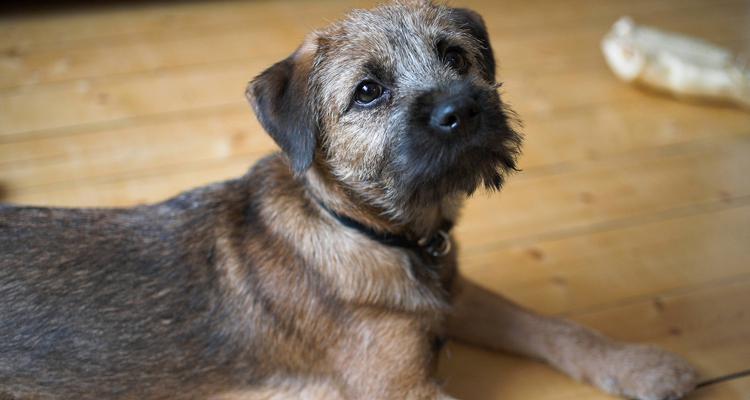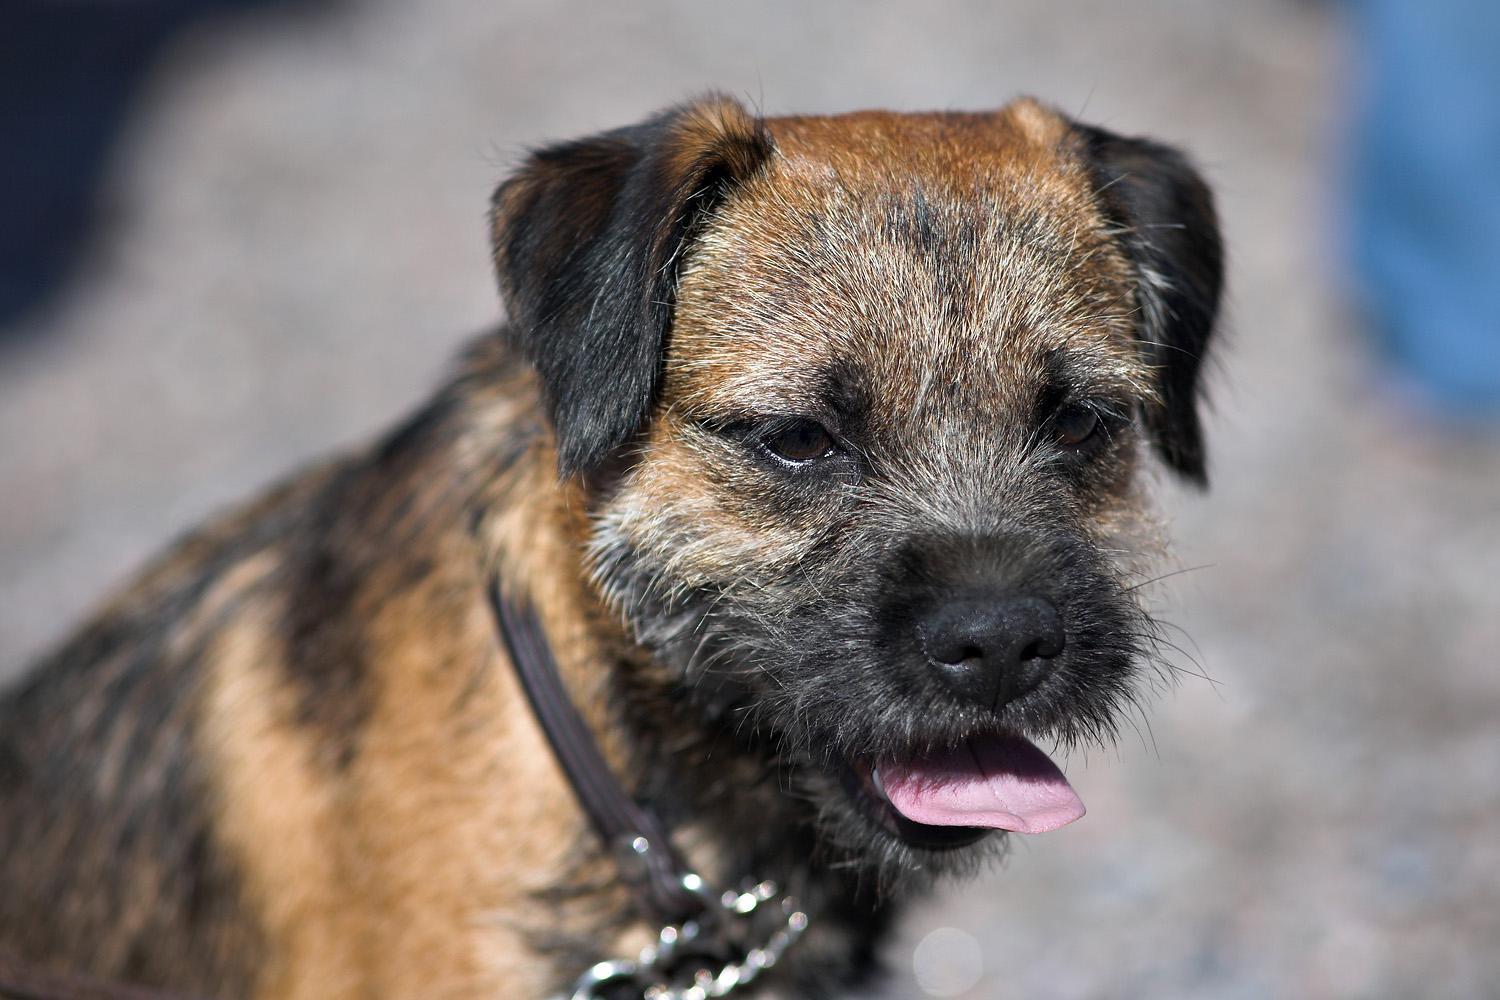The first image is the image on the left, the second image is the image on the right. Assess this claim about the two images: "The animal in one of the images is on all fours and facing right". Correct or not? Answer yes or no. No. The first image is the image on the left, the second image is the image on the right. Analyze the images presented: Is the assertion "Right image shows a dog standing in profile on grass." valid? Answer yes or no. No. 